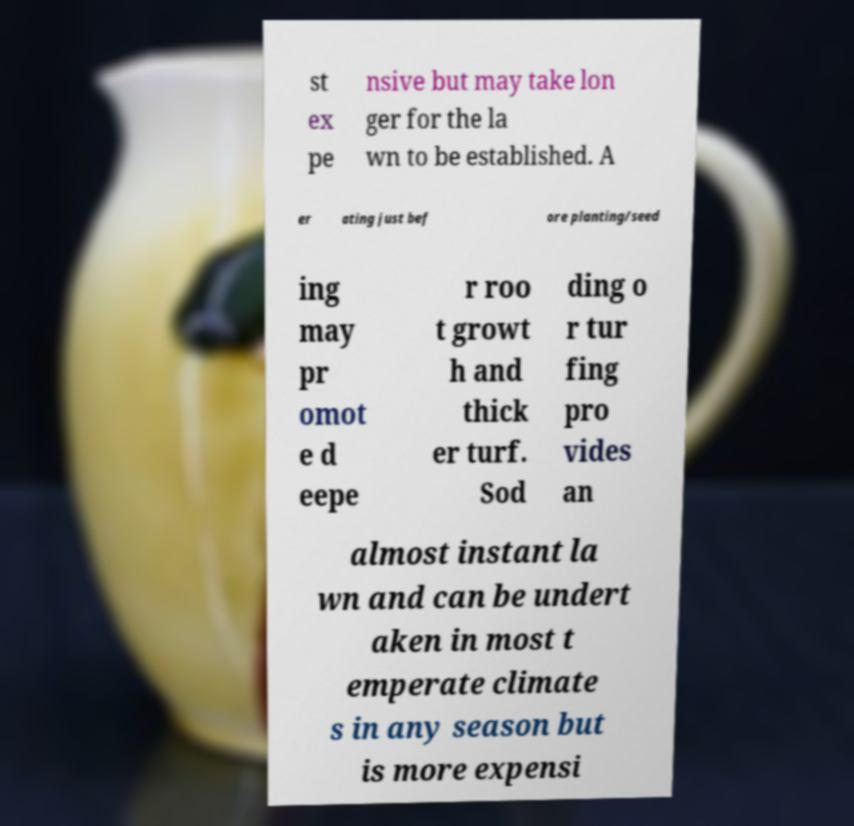There's text embedded in this image that I need extracted. Can you transcribe it verbatim? st ex pe nsive but may take lon ger for the la wn to be established. A er ating just bef ore planting/seed ing may pr omot e d eepe r roo t growt h and thick er turf. Sod ding o r tur fing pro vides an almost instant la wn and can be undert aken in most t emperate climate s in any season but is more expensi 